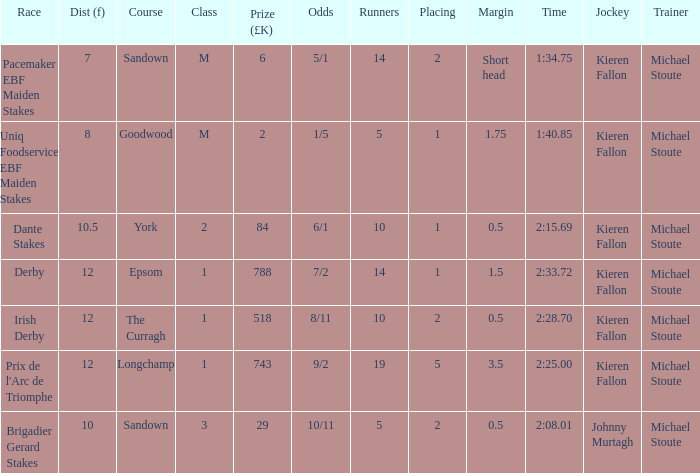Name the least runners with dist of 10.5 10.0. 